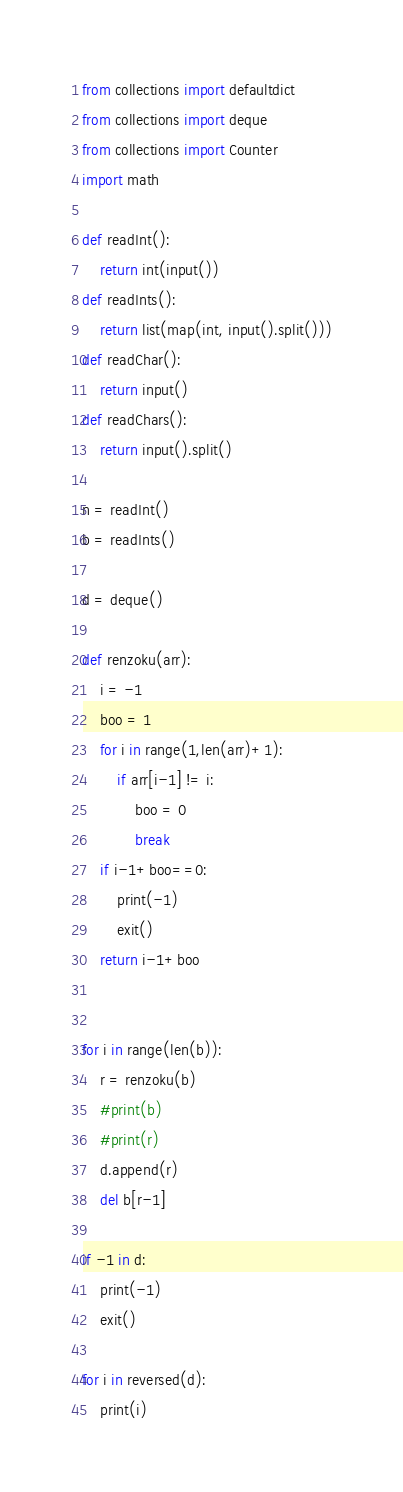Convert code to text. <code><loc_0><loc_0><loc_500><loc_500><_Python_>from collections import defaultdict
from collections import deque
from collections import Counter
import math

def readInt():
	return int(input())
def readInts():
	return list(map(int, input().split()))
def readChar():
	return input()
def readChars():
	return input().split()

n = readInt()
b = readInts()

d = deque()

def renzoku(arr):
	i = -1
	boo = 1
	for i in range(1,len(arr)+1):
		if arr[i-1] != i:
			boo = 0
			break
	if i-1+boo==0:
		print(-1)
		exit()
	return i-1+boo


for i in range(len(b)):
	r = renzoku(b)
	#print(b)
	#print(r)
	d.append(r)
	del b[r-1]

if -1 in d:
	print(-1)
	exit()

for i in reversed(d):
	print(i)</code> 